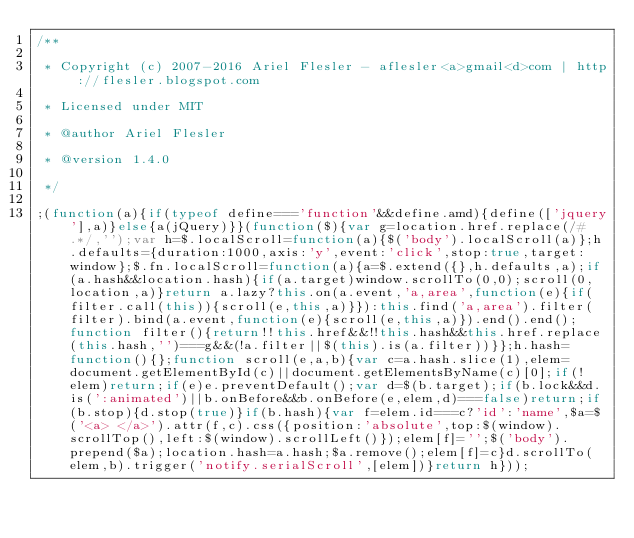Convert code to text. <code><loc_0><loc_0><loc_500><loc_500><_JavaScript_>/**
 * Copyright (c) 2007-2016 Ariel Flesler - aflesler<a>gmail<d>com | http://flesler.blogspot.com
 * Licensed under MIT
 * @author Ariel Flesler
 * @version 1.4.0
 */
;(function(a){if(typeof define==='function'&&define.amd){define(['jquery'],a)}else{a(jQuery)}}(function($){var g=location.href.replace(/#.*/,'');var h=$.localScroll=function(a){$('body').localScroll(a)};h.defaults={duration:1000,axis:'y',event:'click',stop:true,target:window};$.fn.localScroll=function(a){a=$.extend({},h.defaults,a);if(a.hash&&location.hash){if(a.target)window.scrollTo(0,0);scroll(0,location,a)}return a.lazy?this.on(a.event,'a,area',function(e){if(filter.call(this)){scroll(e,this,a)}}):this.find('a,area').filter(filter).bind(a.event,function(e){scroll(e,this,a)}).end().end();function filter(){return!!this.href&&!!this.hash&&this.href.replace(this.hash,'')===g&&(!a.filter||$(this).is(a.filter))}};h.hash=function(){};function scroll(e,a,b){var c=a.hash.slice(1),elem=document.getElementById(c)||document.getElementsByName(c)[0];if(!elem)return;if(e)e.preventDefault();var d=$(b.target);if(b.lock&&d.is(':animated')||b.onBefore&&b.onBefore(e,elem,d)===false)return;if(b.stop){d.stop(true)}if(b.hash){var f=elem.id===c?'id':'name',$a=$('<a> </a>').attr(f,c).css({position:'absolute',top:$(window).scrollTop(),left:$(window).scrollLeft()});elem[f]='';$('body').prepend($a);location.hash=a.hash;$a.remove();elem[f]=c}d.scrollTo(elem,b).trigger('notify.serialScroll',[elem])}return h}));</code> 